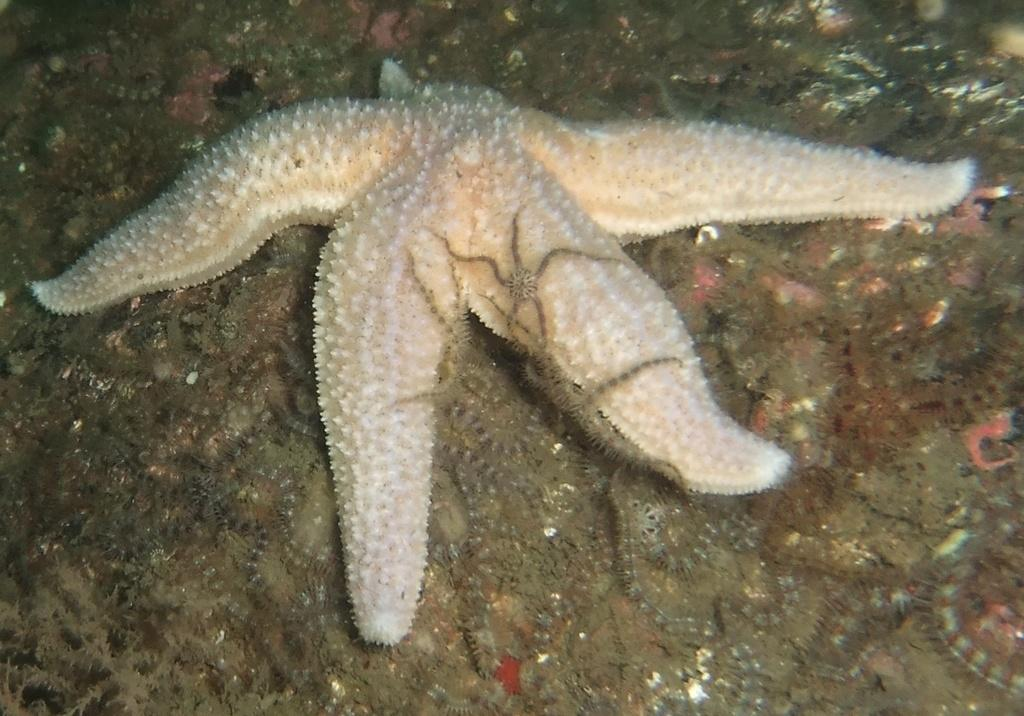What is the main subject of the image? The main subject of the image is a starfish. Where is the starfish located? The starfish is inside the water. Are there any other starfishes in the image? Yes, there are small starfishes near the larger starfish. What is the amount of money listed on the receipt in the image? There is no receipt present in the image, so we cannot determine the amount of money listed on it. 